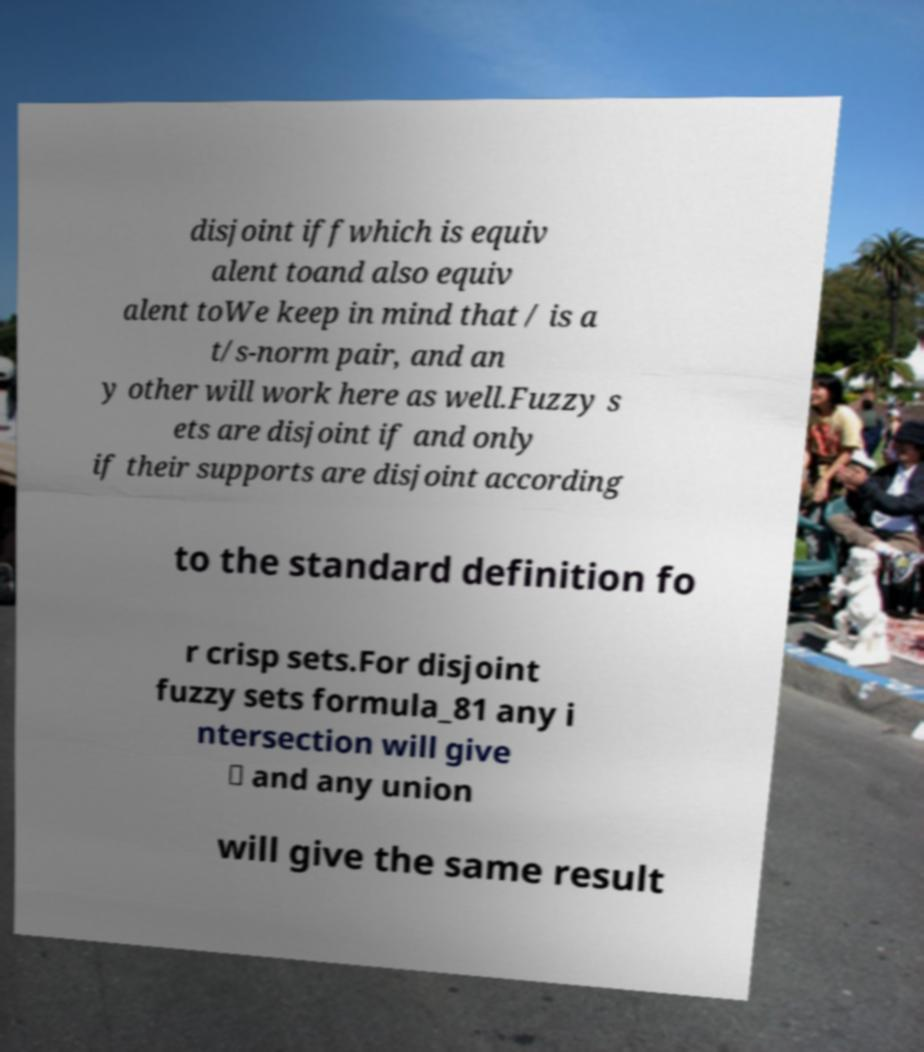I need the written content from this picture converted into text. Can you do that? disjoint iffwhich is equiv alent toand also equiv alent toWe keep in mind that / is a t/s-norm pair, and an y other will work here as well.Fuzzy s ets are disjoint if and only if their supports are disjoint according to the standard definition fo r crisp sets.For disjoint fuzzy sets formula_81 any i ntersection will give ∅ and any union will give the same result 